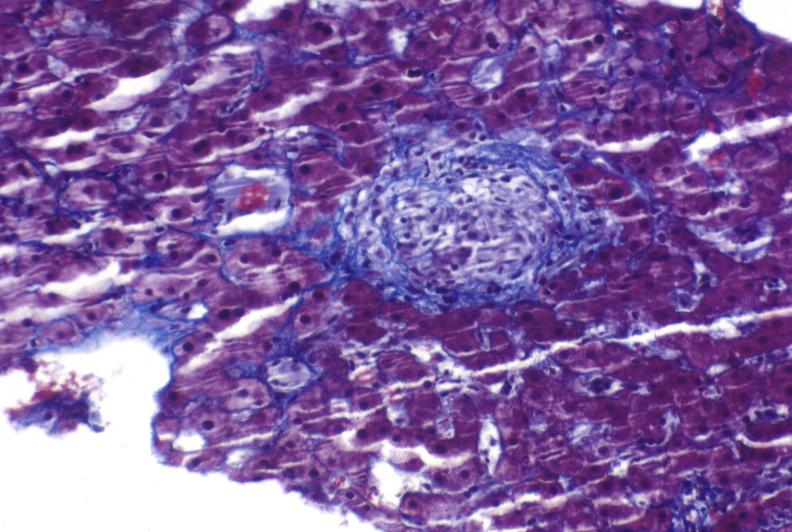what is present?
Answer the question using a single word or phrase. Hepatobiliary 